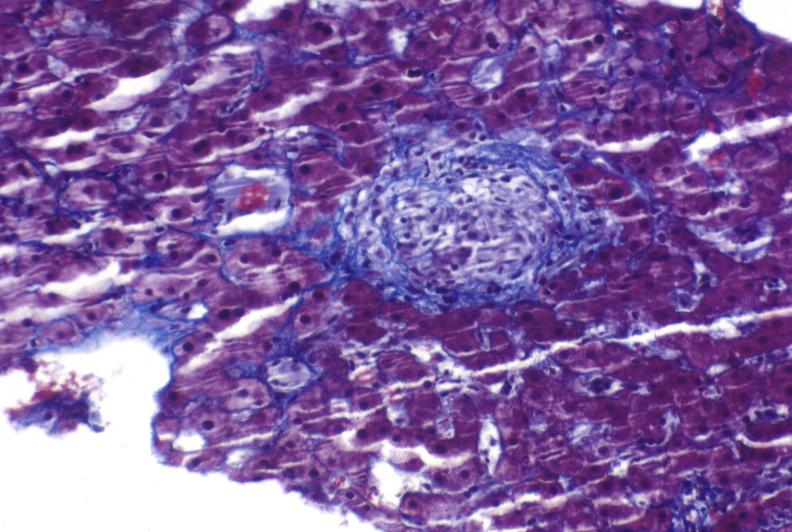what is present?
Answer the question using a single word or phrase. Hepatobiliary 